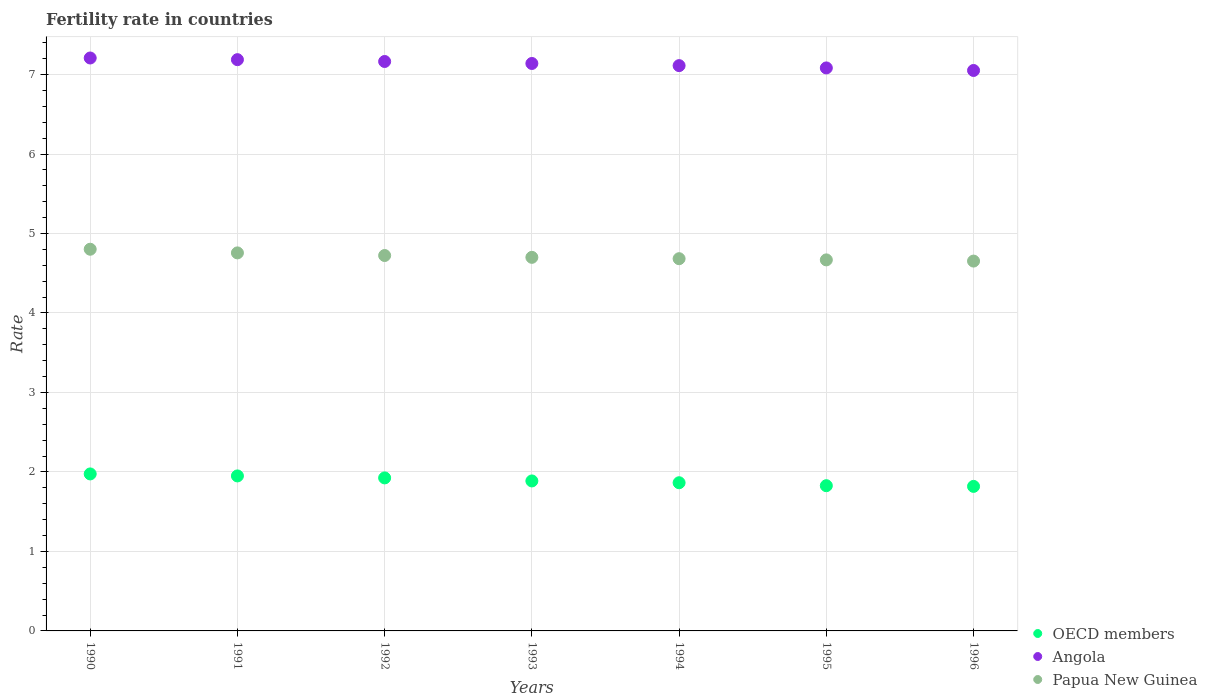How many different coloured dotlines are there?
Offer a very short reply. 3. Is the number of dotlines equal to the number of legend labels?
Your answer should be compact. Yes. What is the fertility rate in Angola in 1991?
Ensure brevity in your answer.  7.19. Across all years, what is the maximum fertility rate in Papua New Guinea?
Your answer should be compact. 4.8. Across all years, what is the minimum fertility rate in Angola?
Your response must be concise. 7.05. In which year was the fertility rate in Angola maximum?
Provide a short and direct response. 1990. What is the total fertility rate in Papua New Guinea in the graph?
Give a very brief answer. 32.98. What is the difference between the fertility rate in Papua New Guinea in 1995 and that in 1996?
Offer a very short reply. 0.02. What is the difference between the fertility rate in Papua New Guinea in 1993 and the fertility rate in OECD members in 1995?
Provide a short and direct response. 2.87. What is the average fertility rate in Papua New Guinea per year?
Give a very brief answer. 4.71. In the year 1996, what is the difference between the fertility rate in Angola and fertility rate in OECD members?
Your response must be concise. 5.23. What is the ratio of the fertility rate in OECD members in 1991 to that in 1993?
Your answer should be very brief. 1.03. Is the difference between the fertility rate in Angola in 1992 and 1995 greater than the difference between the fertility rate in OECD members in 1992 and 1995?
Keep it short and to the point. No. What is the difference between the highest and the second highest fertility rate in OECD members?
Give a very brief answer. 0.03. What is the difference between the highest and the lowest fertility rate in Angola?
Keep it short and to the point. 0.16. In how many years, is the fertility rate in Angola greater than the average fertility rate in Angola taken over all years?
Keep it short and to the point. 4. Is it the case that in every year, the sum of the fertility rate in Papua New Guinea and fertility rate in OECD members  is greater than the fertility rate in Angola?
Keep it short and to the point. No. Does the fertility rate in Papua New Guinea monotonically increase over the years?
Make the answer very short. No. How many dotlines are there?
Provide a succinct answer. 3. Does the graph contain grids?
Your response must be concise. Yes. How many legend labels are there?
Provide a short and direct response. 3. How are the legend labels stacked?
Provide a succinct answer. Vertical. What is the title of the graph?
Your answer should be very brief. Fertility rate in countries. Does "High income" appear as one of the legend labels in the graph?
Your response must be concise. No. What is the label or title of the X-axis?
Offer a very short reply. Years. What is the label or title of the Y-axis?
Your response must be concise. Rate. What is the Rate in OECD members in 1990?
Offer a terse response. 1.98. What is the Rate in Angola in 1990?
Offer a very short reply. 7.21. What is the Rate of Papua New Guinea in 1990?
Ensure brevity in your answer.  4.8. What is the Rate of OECD members in 1991?
Provide a succinct answer. 1.95. What is the Rate of Angola in 1991?
Make the answer very short. 7.19. What is the Rate in Papua New Guinea in 1991?
Keep it short and to the point. 4.76. What is the Rate in OECD members in 1992?
Make the answer very short. 1.93. What is the Rate of Angola in 1992?
Your response must be concise. 7.16. What is the Rate of Papua New Guinea in 1992?
Your answer should be compact. 4.72. What is the Rate of OECD members in 1993?
Ensure brevity in your answer.  1.89. What is the Rate of Angola in 1993?
Offer a very short reply. 7.14. What is the Rate in Papua New Guinea in 1993?
Offer a terse response. 4.7. What is the Rate in OECD members in 1994?
Provide a short and direct response. 1.86. What is the Rate of Angola in 1994?
Provide a short and direct response. 7.11. What is the Rate of Papua New Guinea in 1994?
Make the answer very short. 4.68. What is the Rate of OECD members in 1995?
Your response must be concise. 1.83. What is the Rate of Angola in 1995?
Offer a terse response. 7.08. What is the Rate in Papua New Guinea in 1995?
Your answer should be very brief. 4.67. What is the Rate in OECD members in 1996?
Make the answer very short. 1.82. What is the Rate in Angola in 1996?
Offer a terse response. 7.05. What is the Rate of Papua New Guinea in 1996?
Provide a short and direct response. 4.65. Across all years, what is the maximum Rate in OECD members?
Make the answer very short. 1.98. Across all years, what is the maximum Rate in Angola?
Your response must be concise. 7.21. Across all years, what is the maximum Rate in Papua New Guinea?
Provide a short and direct response. 4.8. Across all years, what is the minimum Rate of OECD members?
Your answer should be very brief. 1.82. Across all years, what is the minimum Rate in Angola?
Provide a short and direct response. 7.05. Across all years, what is the minimum Rate in Papua New Guinea?
Provide a succinct answer. 4.65. What is the total Rate of OECD members in the graph?
Keep it short and to the point. 13.25. What is the total Rate of Angola in the graph?
Keep it short and to the point. 49.94. What is the total Rate of Papua New Guinea in the graph?
Your answer should be very brief. 32.98. What is the difference between the Rate of OECD members in 1990 and that in 1991?
Keep it short and to the point. 0.03. What is the difference between the Rate of Angola in 1990 and that in 1991?
Your answer should be compact. 0.02. What is the difference between the Rate of Papua New Guinea in 1990 and that in 1991?
Keep it short and to the point. 0.05. What is the difference between the Rate in Angola in 1990 and that in 1992?
Offer a very short reply. 0.04. What is the difference between the Rate in Papua New Guinea in 1990 and that in 1992?
Ensure brevity in your answer.  0.08. What is the difference between the Rate of OECD members in 1990 and that in 1993?
Offer a terse response. 0.09. What is the difference between the Rate in Angola in 1990 and that in 1993?
Give a very brief answer. 0.07. What is the difference between the Rate of Papua New Guinea in 1990 and that in 1993?
Provide a short and direct response. 0.1. What is the difference between the Rate of OECD members in 1990 and that in 1994?
Offer a very short reply. 0.11. What is the difference between the Rate in Angola in 1990 and that in 1994?
Give a very brief answer. 0.1. What is the difference between the Rate of Papua New Guinea in 1990 and that in 1994?
Your answer should be very brief. 0.12. What is the difference between the Rate of OECD members in 1990 and that in 1995?
Your answer should be very brief. 0.15. What is the difference between the Rate of Angola in 1990 and that in 1995?
Provide a succinct answer. 0.12. What is the difference between the Rate of Papua New Guinea in 1990 and that in 1995?
Provide a short and direct response. 0.13. What is the difference between the Rate of OECD members in 1990 and that in 1996?
Your response must be concise. 0.16. What is the difference between the Rate in Angola in 1990 and that in 1996?
Offer a very short reply. 0.16. What is the difference between the Rate of Papua New Guinea in 1990 and that in 1996?
Your answer should be compact. 0.15. What is the difference between the Rate of OECD members in 1991 and that in 1992?
Your answer should be compact. 0.02. What is the difference between the Rate in Angola in 1991 and that in 1992?
Provide a short and direct response. 0.02. What is the difference between the Rate in Papua New Guinea in 1991 and that in 1992?
Your answer should be very brief. 0.03. What is the difference between the Rate of OECD members in 1991 and that in 1993?
Ensure brevity in your answer.  0.06. What is the difference between the Rate in Angola in 1991 and that in 1993?
Your answer should be very brief. 0.05. What is the difference between the Rate of Papua New Guinea in 1991 and that in 1993?
Keep it short and to the point. 0.06. What is the difference between the Rate in OECD members in 1991 and that in 1994?
Your answer should be very brief. 0.09. What is the difference between the Rate of Angola in 1991 and that in 1994?
Your response must be concise. 0.07. What is the difference between the Rate of Papua New Guinea in 1991 and that in 1994?
Your answer should be compact. 0.07. What is the difference between the Rate of OECD members in 1991 and that in 1995?
Your answer should be very brief. 0.12. What is the difference between the Rate of Angola in 1991 and that in 1995?
Your response must be concise. 0.1. What is the difference between the Rate in Papua New Guinea in 1991 and that in 1995?
Your answer should be compact. 0.09. What is the difference between the Rate in OECD members in 1991 and that in 1996?
Your answer should be very brief. 0.13. What is the difference between the Rate in Angola in 1991 and that in 1996?
Your answer should be compact. 0.14. What is the difference between the Rate in Papua New Guinea in 1991 and that in 1996?
Your answer should be compact. 0.1. What is the difference between the Rate in OECD members in 1992 and that in 1993?
Your answer should be very brief. 0.04. What is the difference between the Rate in Angola in 1992 and that in 1993?
Your answer should be very brief. 0.03. What is the difference between the Rate in Papua New Guinea in 1992 and that in 1993?
Offer a terse response. 0.02. What is the difference between the Rate in OECD members in 1992 and that in 1994?
Keep it short and to the point. 0.06. What is the difference between the Rate of Angola in 1992 and that in 1994?
Offer a very short reply. 0.05. What is the difference between the Rate of OECD members in 1992 and that in 1995?
Provide a succinct answer. 0.1. What is the difference between the Rate of Angola in 1992 and that in 1995?
Your answer should be compact. 0.08. What is the difference between the Rate of Papua New Guinea in 1992 and that in 1995?
Offer a very short reply. 0.06. What is the difference between the Rate in OECD members in 1992 and that in 1996?
Your answer should be very brief. 0.11. What is the difference between the Rate in Angola in 1992 and that in 1996?
Your answer should be very brief. 0.11. What is the difference between the Rate in Papua New Guinea in 1992 and that in 1996?
Ensure brevity in your answer.  0.07. What is the difference between the Rate in OECD members in 1993 and that in 1994?
Your answer should be very brief. 0.02. What is the difference between the Rate of Angola in 1993 and that in 1994?
Provide a short and direct response. 0.03. What is the difference between the Rate of Papua New Guinea in 1993 and that in 1994?
Make the answer very short. 0.02. What is the difference between the Rate of OECD members in 1993 and that in 1995?
Provide a succinct answer. 0.06. What is the difference between the Rate in Angola in 1993 and that in 1995?
Ensure brevity in your answer.  0.06. What is the difference between the Rate of Papua New Guinea in 1993 and that in 1995?
Ensure brevity in your answer.  0.03. What is the difference between the Rate in OECD members in 1993 and that in 1996?
Make the answer very short. 0.07. What is the difference between the Rate in Angola in 1993 and that in 1996?
Provide a short and direct response. 0.09. What is the difference between the Rate of Papua New Guinea in 1993 and that in 1996?
Keep it short and to the point. 0.05. What is the difference between the Rate of OECD members in 1994 and that in 1995?
Your response must be concise. 0.04. What is the difference between the Rate in Angola in 1994 and that in 1995?
Your answer should be compact. 0.03. What is the difference between the Rate in Papua New Guinea in 1994 and that in 1995?
Provide a succinct answer. 0.01. What is the difference between the Rate of OECD members in 1994 and that in 1996?
Provide a succinct answer. 0.05. What is the difference between the Rate of Angola in 1994 and that in 1996?
Make the answer very short. 0.06. What is the difference between the Rate of OECD members in 1995 and that in 1996?
Your response must be concise. 0.01. What is the difference between the Rate of Angola in 1995 and that in 1996?
Make the answer very short. 0.03. What is the difference between the Rate of Papua New Guinea in 1995 and that in 1996?
Your answer should be compact. 0.01. What is the difference between the Rate in OECD members in 1990 and the Rate in Angola in 1991?
Your answer should be very brief. -5.21. What is the difference between the Rate in OECD members in 1990 and the Rate in Papua New Guinea in 1991?
Your answer should be compact. -2.78. What is the difference between the Rate of Angola in 1990 and the Rate of Papua New Guinea in 1991?
Offer a terse response. 2.45. What is the difference between the Rate in OECD members in 1990 and the Rate in Angola in 1992?
Ensure brevity in your answer.  -5.19. What is the difference between the Rate of OECD members in 1990 and the Rate of Papua New Guinea in 1992?
Keep it short and to the point. -2.75. What is the difference between the Rate in Angola in 1990 and the Rate in Papua New Guinea in 1992?
Keep it short and to the point. 2.48. What is the difference between the Rate of OECD members in 1990 and the Rate of Angola in 1993?
Offer a terse response. -5.16. What is the difference between the Rate in OECD members in 1990 and the Rate in Papua New Guinea in 1993?
Your response must be concise. -2.72. What is the difference between the Rate in Angola in 1990 and the Rate in Papua New Guinea in 1993?
Your answer should be compact. 2.51. What is the difference between the Rate in OECD members in 1990 and the Rate in Angola in 1994?
Ensure brevity in your answer.  -5.14. What is the difference between the Rate of OECD members in 1990 and the Rate of Papua New Guinea in 1994?
Your answer should be compact. -2.71. What is the difference between the Rate of Angola in 1990 and the Rate of Papua New Guinea in 1994?
Make the answer very short. 2.52. What is the difference between the Rate of OECD members in 1990 and the Rate of Angola in 1995?
Ensure brevity in your answer.  -5.11. What is the difference between the Rate in OECD members in 1990 and the Rate in Papua New Guinea in 1995?
Keep it short and to the point. -2.69. What is the difference between the Rate in Angola in 1990 and the Rate in Papua New Guinea in 1995?
Ensure brevity in your answer.  2.54. What is the difference between the Rate in OECD members in 1990 and the Rate in Angola in 1996?
Give a very brief answer. -5.08. What is the difference between the Rate in OECD members in 1990 and the Rate in Papua New Guinea in 1996?
Make the answer very short. -2.68. What is the difference between the Rate in Angola in 1990 and the Rate in Papua New Guinea in 1996?
Provide a short and direct response. 2.56. What is the difference between the Rate of OECD members in 1991 and the Rate of Angola in 1992?
Make the answer very short. -5.21. What is the difference between the Rate in OECD members in 1991 and the Rate in Papua New Guinea in 1992?
Provide a short and direct response. -2.77. What is the difference between the Rate in Angola in 1991 and the Rate in Papua New Guinea in 1992?
Your response must be concise. 2.46. What is the difference between the Rate of OECD members in 1991 and the Rate of Angola in 1993?
Offer a terse response. -5.19. What is the difference between the Rate in OECD members in 1991 and the Rate in Papua New Guinea in 1993?
Provide a succinct answer. -2.75. What is the difference between the Rate of Angola in 1991 and the Rate of Papua New Guinea in 1993?
Offer a very short reply. 2.49. What is the difference between the Rate of OECD members in 1991 and the Rate of Angola in 1994?
Your answer should be compact. -5.16. What is the difference between the Rate of OECD members in 1991 and the Rate of Papua New Guinea in 1994?
Offer a terse response. -2.73. What is the difference between the Rate in Angola in 1991 and the Rate in Papua New Guinea in 1994?
Offer a very short reply. 2.5. What is the difference between the Rate in OECD members in 1991 and the Rate in Angola in 1995?
Make the answer very short. -5.13. What is the difference between the Rate of OECD members in 1991 and the Rate of Papua New Guinea in 1995?
Provide a succinct answer. -2.72. What is the difference between the Rate of Angola in 1991 and the Rate of Papua New Guinea in 1995?
Offer a terse response. 2.52. What is the difference between the Rate in OECD members in 1991 and the Rate in Angola in 1996?
Provide a succinct answer. -5.1. What is the difference between the Rate in OECD members in 1991 and the Rate in Papua New Guinea in 1996?
Your response must be concise. -2.7. What is the difference between the Rate of Angola in 1991 and the Rate of Papua New Guinea in 1996?
Provide a short and direct response. 2.53. What is the difference between the Rate of OECD members in 1992 and the Rate of Angola in 1993?
Your response must be concise. -5.21. What is the difference between the Rate in OECD members in 1992 and the Rate in Papua New Guinea in 1993?
Ensure brevity in your answer.  -2.77. What is the difference between the Rate of Angola in 1992 and the Rate of Papua New Guinea in 1993?
Your response must be concise. 2.46. What is the difference between the Rate in OECD members in 1992 and the Rate in Angola in 1994?
Ensure brevity in your answer.  -5.19. What is the difference between the Rate of OECD members in 1992 and the Rate of Papua New Guinea in 1994?
Provide a short and direct response. -2.76. What is the difference between the Rate of Angola in 1992 and the Rate of Papua New Guinea in 1994?
Your response must be concise. 2.48. What is the difference between the Rate of OECD members in 1992 and the Rate of Angola in 1995?
Provide a succinct answer. -5.16. What is the difference between the Rate of OECD members in 1992 and the Rate of Papua New Guinea in 1995?
Offer a very short reply. -2.74. What is the difference between the Rate of Angola in 1992 and the Rate of Papua New Guinea in 1995?
Make the answer very short. 2.5. What is the difference between the Rate of OECD members in 1992 and the Rate of Angola in 1996?
Provide a succinct answer. -5.13. What is the difference between the Rate in OECD members in 1992 and the Rate in Papua New Guinea in 1996?
Your response must be concise. -2.73. What is the difference between the Rate of Angola in 1992 and the Rate of Papua New Guinea in 1996?
Offer a terse response. 2.51. What is the difference between the Rate in OECD members in 1993 and the Rate in Angola in 1994?
Your answer should be compact. -5.23. What is the difference between the Rate of OECD members in 1993 and the Rate of Papua New Guinea in 1994?
Make the answer very short. -2.8. What is the difference between the Rate in Angola in 1993 and the Rate in Papua New Guinea in 1994?
Provide a succinct answer. 2.46. What is the difference between the Rate of OECD members in 1993 and the Rate of Angola in 1995?
Ensure brevity in your answer.  -5.2. What is the difference between the Rate of OECD members in 1993 and the Rate of Papua New Guinea in 1995?
Your answer should be compact. -2.78. What is the difference between the Rate of Angola in 1993 and the Rate of Papua New Guinea in 1995?
Your answer should be compact. 2.47. What is the difference between the Rate in OECD members in 1993 and the Rate in Angola in 1996?
Offer a terse response. -5.16. What is the difference between the Rate of OECD members in 1993 and the Rate of Papua New Guinea in 1996?
Your answer should be very brief. -2.77. What is the difference between the Rate in Angola in 1993 and the Rate in Papua New Guinea in 1996?
Offer a very short reply. 2.49. What is the difference between the Rate in OECD members in 1994 and the Rate in Angola in 1995?
Your answer should be compact. -5.22. What is the difference between the Rate in OECD members in 1994 and the Rate in Papua New Guinea in 1995?
Offer a very short reply. -2.8. What is the difference between the Rate in Angola in 1994 and the Rate in Papua New Guinea in 1995?
Your answer should be very brief. 2.44. What is the difference between the Rate of OECD members in 1994 and the Rate of Angola in 1996?
Offer a very short reply. -5.19. What is the difference between the Rate of OECD members in 1994 and the Rate of Papua New Guinea in 1996?
Ensure brevity in your answer.  -2.79. What is the difference between the Rate in Angola in 1994 and the Rate in Papua New Guinea in 1996?
Make the answer very short. 2.46. What is the difference between the Rate of OECD members in 1995 and the Rate of Angola in 1996?
Keep it short and to the point. -5.22. What is the difference between the Rate in OECD members in 1995 and the Rate in Papua New Guinea in 1996?
Your answer should be compact. -2.83. What is the difference between the Rate in Angola in 1995 and the Rate in Papua New Guinea in 1996?
Provide a short and direct response. 2.43. What is the average Rate of OECD members per year?
Make the answer very short. 1.89. What is the average Rate of Angola per year?
Your response must be concise. 7.13. What is the average Rate in Papua New Guinea per year?
Give a very brief answer. 4.71. In the year 1990, what is the difference between the Rate in OECD members and Rate in Angola?
Ensure brevity in your answer.  -5.23. In the year 1990, what is the difference between the Rate in OECD members and Rate in Papua New Guinea?
Offer a very short reply. -2.83. In the year 1990, what is the difference between the Rate of Angola and Rate of Papua New Guinea?
Offer a very short reply. 2.41. In the year 1991, what is the difference between the Rate in OECD members and Rate in Angola?
Keep it short and to the point. -5.24. In the year 1991, what is the difference between the Rate in OECD members and Rate in Papua New Guinea?
Offer a terse response. -2.81. In the year 1991, what is the difference between the Rate in Angola and Rate in Papua New Guinea?
Give a very brief answer. 2.43. In the year 1992, what is the difference between the Rate of OECD members and Rate of Angola?
Your answer should be compact. -5.24. In the year 1992, what is the difference between the Rate in OECD members and Rate in Papua New Guinea?
Your answer should be compact. -2.8. In the year 1992, what is the difference between the Rate in Angola and Rate in Papua New Guinea?
Your answer should be very brief. 2.44. In the year 1993, what is the difference between the Rate of OECD members and Rate of Angola?
Offer a terse response. -5.25. In the year 1993, what is the difference between the Rate of OECD members and Rate of Papua New Guinea?
Offer a terse response. -2.81. In the year 1993, what is the difference between the Rate in Angola and Rate in Papua New Guinea?
Your answer should be compact. 2.44. In the year 1994, what is the difference between the Rate of OECD members and Rate of Angola?
Your response must be concise. -5.25. In the year 1994, what is the difference between the Rate in OECD members and Rate in Papua New Guinea?
Offer a terse response. -2.82. In the year 1994, what is the difference between the Rate in Angola and Rate in Papua New Guinea?
Your answer should be very brief. 2.43. In the year 1995, what is the difference between the Rate in OECD members and Rate in Angola?
Ensure brevity in your answer.  -5.26. In the year 1995, what is the difference between the Rate in OECD members and Rate in Papua New Guinea?
Your answer should be compact. -2.84. In the year 1995, what is the difference between the Rate in Angola and Rate in Papua New Guinea?
Offer a very short reply. 2.42. In the year 1996, what is the difference between the Rate in OECD members and Rate in Angola?
Your answer should be very brief. -5.23. In the year 1996, what is the difference between the Rate of OECD members and Rate of Papua New Guinea?
Offer a terse response. -2.83. In the year 1996, what is the difference between the Rate of Angola and Rate of Papua New Guinea?
Offer a very short reply. 2.4. What is the ratio of the Rate in OECD members in 1990 to that in 1991?
Keep it short and to the point. 1.01. What is the ratio of the Rate in Angola in 1990 to that in 1991?
Ensure brevity in your answer.  1. What is the ratio of the Rate in Papua New Guinea in 1990 to that in 1991?
Offer a very short reply. 1.01. What is the ratio of the Rate in OECD members in 1990 to that in 1992?
Make the answer very short. 1.03. What is the ratio of the Rate of Papua New Guinea in 1990 to that in 1992?
Your answer should be very brief. 1.02. What is the ratio of the Rate in OECD members in 1990 to that in 1993?
Keep it short and to the point. 1.05. What is the ratio of the Rate in Angola in 1990 to that in 1993?
Provide a short and direct response. 1.01. What is the ratio of the Rate in Papua New Guinea in 1990 to that in 1993?
Your response must be concise. 1.02. What is the ratio of the Rate of OECD members in 1990 to that in 1994?
Your answer should be compact. 1.06. What is the ratio of the Rate in Angola in 1990 to that in 1994?
Make the answer very short. 1.01. What is the ratio of the Rate in Papua New Guinea in 1990 to that in 1994?
Your response must be concise. 1.03. What is the ratio of the Rate of OECD members in 1990 to that in 1995?
Make the answer very short. 1.08. What is the ratio of the Rate of Angola in 1990 to that in 1995?
Offer a terse response. 1.02. What is the ratio of the Rate of Papua New Guinea in 1990 to that in 1995?
Give a very brief answer. 1.03. What is the ratio of the Rate in OECD members in 1990 to that in 1996?
Your response must be concise. 1.09. What is the ratio of the Rate of Angola in 1990 to that in 1996?
Your answer should be compact. 1.02. What is the ratio of the Rate of Papua New Guinea in 1990 to that in 1996?
Provide a succinct answer. 1.03. What is the ratio of the Rate in OECD members in 1991 to that in 1992?
Ensure brevity in your answer.  1.01. What is the ratio of the Rate of Angola in 1991 to that in 1992?
Keep it short and to the point. 1. What is the ratio of the Rate of Papua New Guinea in 1991 to that in 1992?
Your answer should be very brief. 1.01. What is the ratio of the Rate of OECD members in 1991 to that in 1993?
Make the answer very short. 1.03. What is the ratio of the Rate of Papua New Guinea in 1991 to that in 1993?
Your answer should be compact. 1.01. What is the ratio of the Rate in OECD members in 1991 to that in 1994?
Offer a terse response. 1.05. What is the ratio of the Rate of Angola in 1991 to that in 1994?
Your answer should be compact. 1.01. What is the ratio of the Rate of Papua New Guinea in 1991 to that in 1994?
Provide a succinct answer. 1.02. What is the ratio of the Rate of OECD members in 1991 to that in 1995?
Your response must be concise. 1.07. What is the ratio of the Rate in Angola in 1991 to that in 1995?
Provide a short and direct response. 1.01. What is the ratio of the Rate in Papua New Guinea in 1991 to that in 1995?
Keep it short and to the point. 1.02. What is the ratio of the Rate in OECD members in 1991 to that in 1996?
Offer a very short reply. 1.07. What is the ratio of the Rate in Angola in 1991 to that in 1996?
Keep it short and to the point. 1.02. What is the ratio of the Rate of Papua New Guinea in 1991 to that in 1996?
Make the answer very short. 1.02. What is the ratio of the Rate of OECD members in 1992 to that in 1993?
Ensure brevity in your answer.  1.02. What is the ratio of the Rate in OECD members in 1992 to that in 1994?
Your answer should be compact. 1.03. What is the ratio of the Rate in Angola in 1992 to that in 1994?
Ensure brevity in your answer.  1.01. What is the ratio of the Rate in Papua New Guinea in 1992 to that in 1994?
Provide a short and direct response. 1.01. What is the ratio of the Rate of OECD members in 1992 to that in 1995?
Your response must be concise. 1.05. What is the ratio of the Rate in Angola in 1992 to that in 1995?
Make the answer very short. 1.01. What is the ratio of the Rate of Papua New Guinea in 1992 to that in 1995?
Your answer should be very brief. 1.01. What is the ratio of the Rate of OECD members in 1992 to that in 1996?
Provide a succinct answer. 1.06. What is the ratio of the Rate in OECD members in 1993 to that in 1994?
Make the answer very short. 1.01. What is the ratio of the Rate in OECD members in 1993 to that in 1995?
Provide a short and direct response. 1.03. What is the ratio of the Rate of Angola in 1993 to that in 1995?
Your answer should be very brief. 1.01. What is the ratio of the Rate of OECD members in 1993 to that in 1996?
Ensure brevity in your answer.  1.04. What is the ratio of the Rate of Angola in 1993 to that in 1996?
Give a very brief answer. 1.01. What is the ratio of the Rate in Papua New Guinea in 1993 to that in 1996?
Your answer should be compact. 1.01. What is the ratio of the Rate of OECD members in 1994 to that in 1995?
Your answer should be very brief. 1.02. What is the ratio of the Rate in OECD members in 1994 to that in 1996?
Provide a short and direct response. 1.03. What is the ratio of the Rate in Angola in 1994 to that in 1996?
Offer a very short reply. 1.01. What is the ratio of the Rate in Papua New Guinea in 1994 to that in 1996?
Ensure brevity in your answer.  1.01. What is the ratio of the Rate of Angola in 1995 to that in 1996?
Ensure brevity in your answer.  1. What is the ratio of the Rate in Papua New Guinea in 1995 to that in 1996?
Ensure brevity in your answer.  1. What is the difference between the highest and the second highest Rate in OECD members?
Make the answer very short. 0.03. What is the difference between the highest and the second highest Rate in Angola?
Your answer should be very brief. 0.02. What is the difference between the highest and the second highest Rate in Papua New Guinea?
Your answer should be very brief. 0.05. What is the difference between the highest and the lowest Rate in OECD members?
Keep it short and to the point. 0.16. What is the difference between the highest and the lowest Rate in Angola?
Offer a very short reply. 0.16. What is the difference between the highest and the lowest Rate of Papua New Guinea?
Offer a terse response. 0.15. 